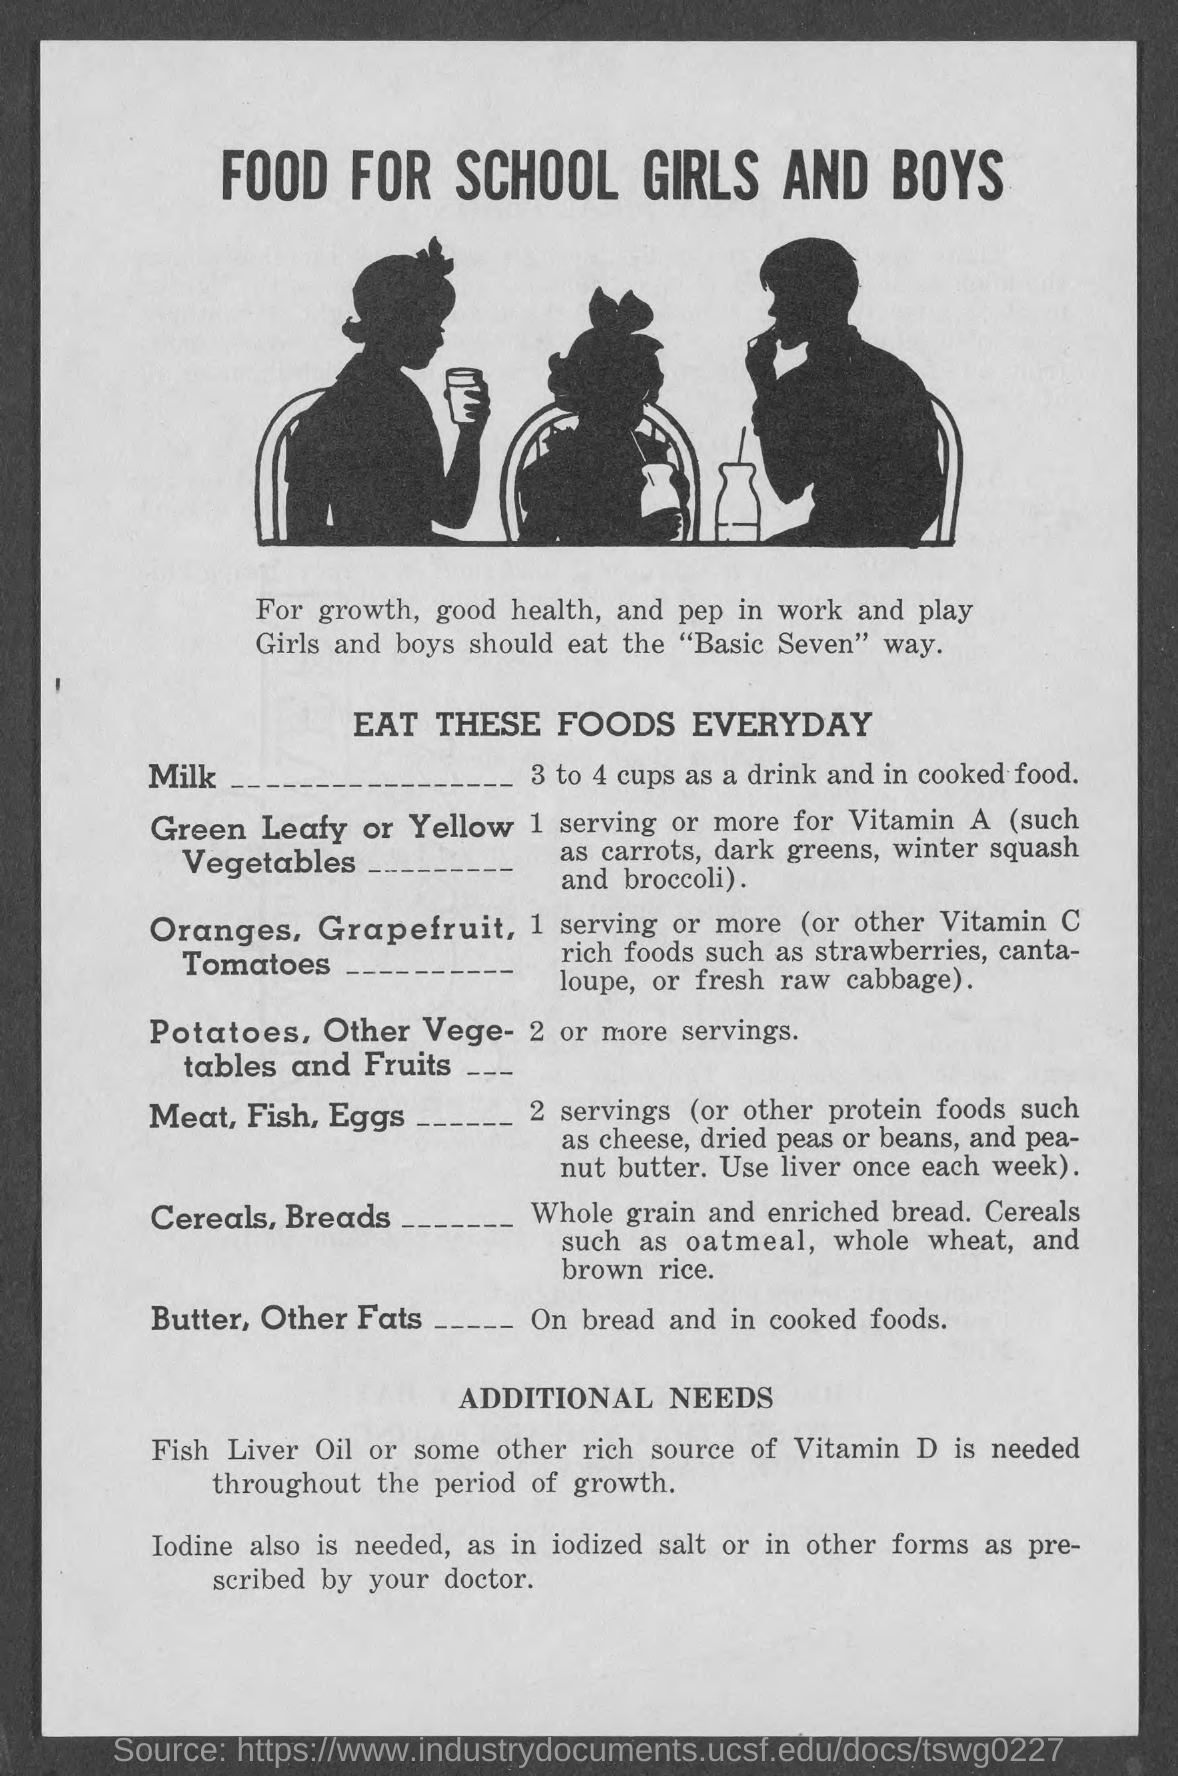Mention a couple of crucial points in this snapshot. It is recommended to consume 3 to 4 cups of milk daily for optimal health. Vitamin D is essential for growth and is required throughout life. 